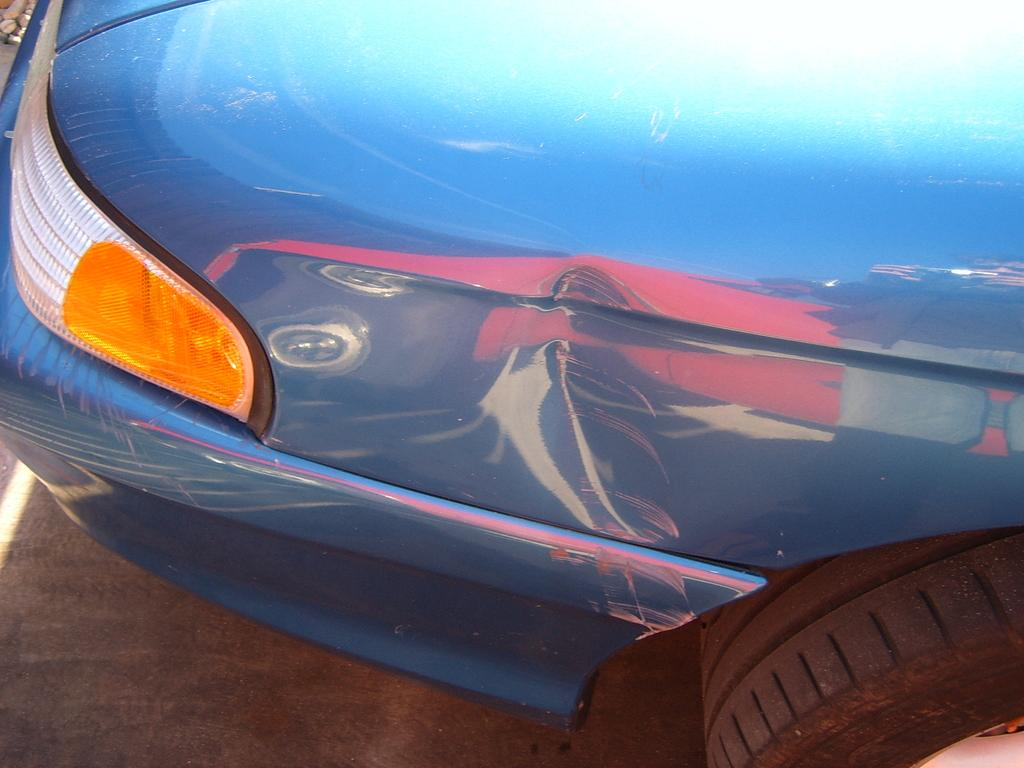What color is the vehicle in the image? The vehicle in the image is blue. What is the condition of the vehicle? The vehicle has a dent mark. Where is the lunchroom located in the image? There is no mention of a lunchroom in the image; it only features a blue vehicle with a dent mark. What type of beast can be seen interacting with the vehicle in the image? There is no beast present in the image; it only features a blue vehicle with a dent mark. 